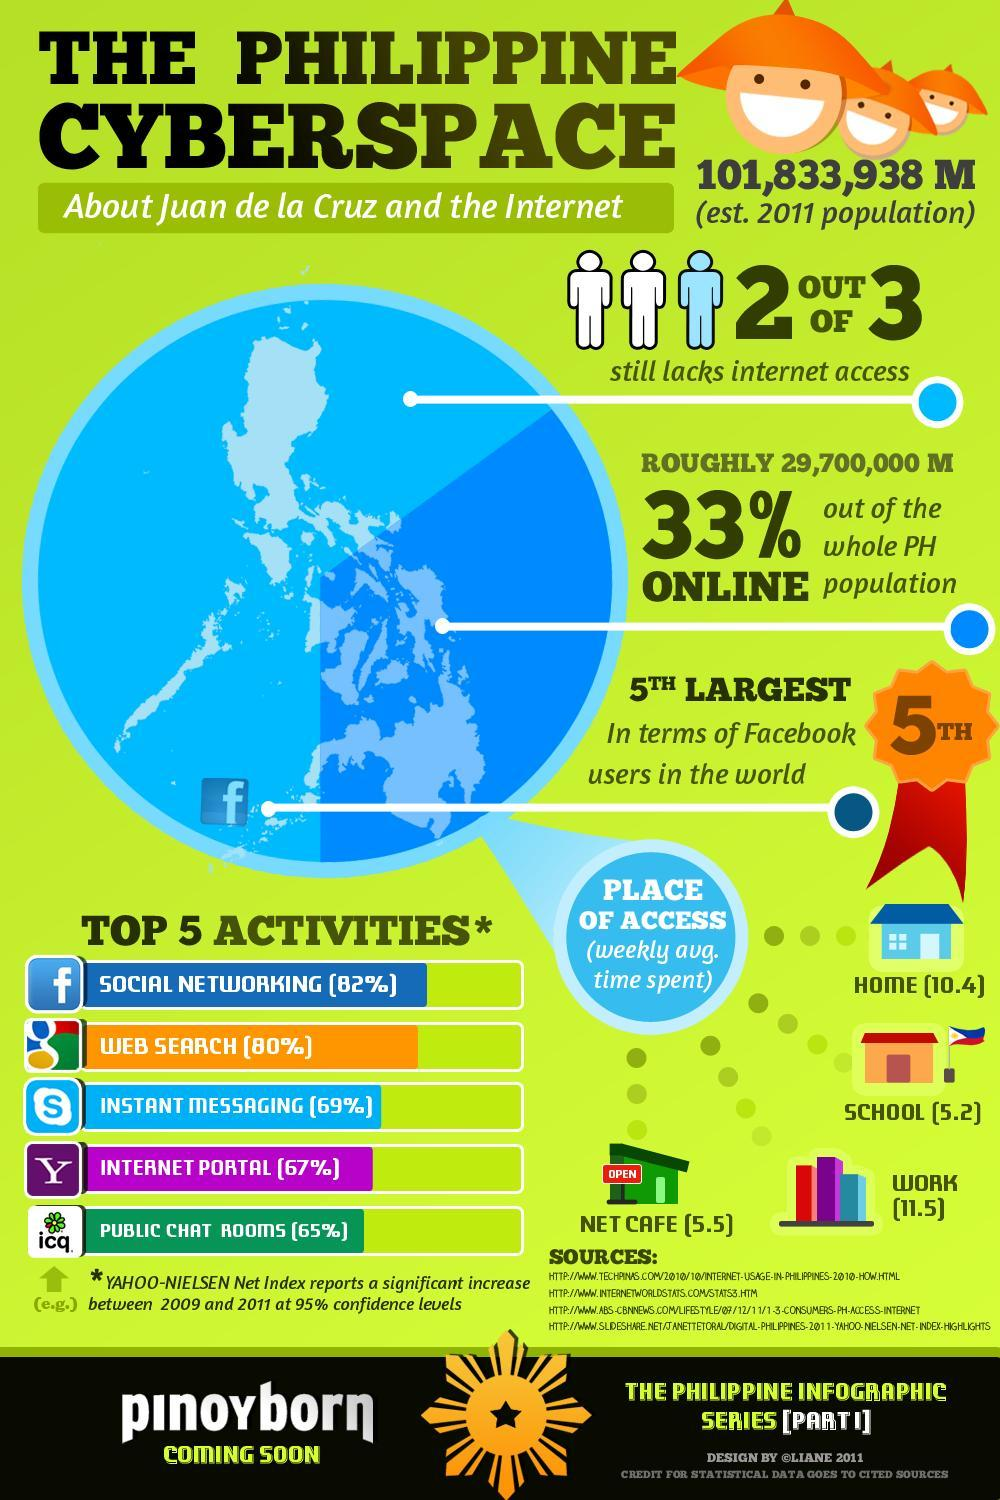Roughly what percent of the population do not have internet access?
Answer the question with a short phrase. 67% The weekly average time spent is lowest from which place of access? School Which place shows the highest weekly average time spent? work Which is the second most used internet activity? web search 